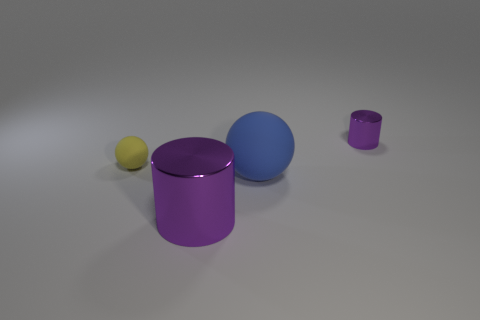Subtract 1 cylinders. How many cylinders are left? 1 Add 2 small yellow metallic things. How many objects exist? 6 Subtract all yellow cylinders. How many gray spheres are left? 0 Subtract all shiny objects. Subtract all large cyan shiny objects. How many objects are left? 2 Add 3 small metallic cylinders. How many small metallic cylinders are left? 4 Add 3 small objects. How many small objects exist? 5 Subtract 0 cyan cubes. How many objects are left? 4 Subtract all blue balls. Subtract all green cylinders. How many balls are left? 1 